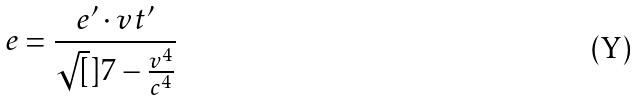<formula> <loc_0><loc_0><loc_500><loc_500>e = \frac { e ^ { \prime } \cdot v t ^ { \prime } } { \sqrt { [ } ] { 7 - \frac { v ^ { 4 } } { c ^ { 4 } } } }</formula> 